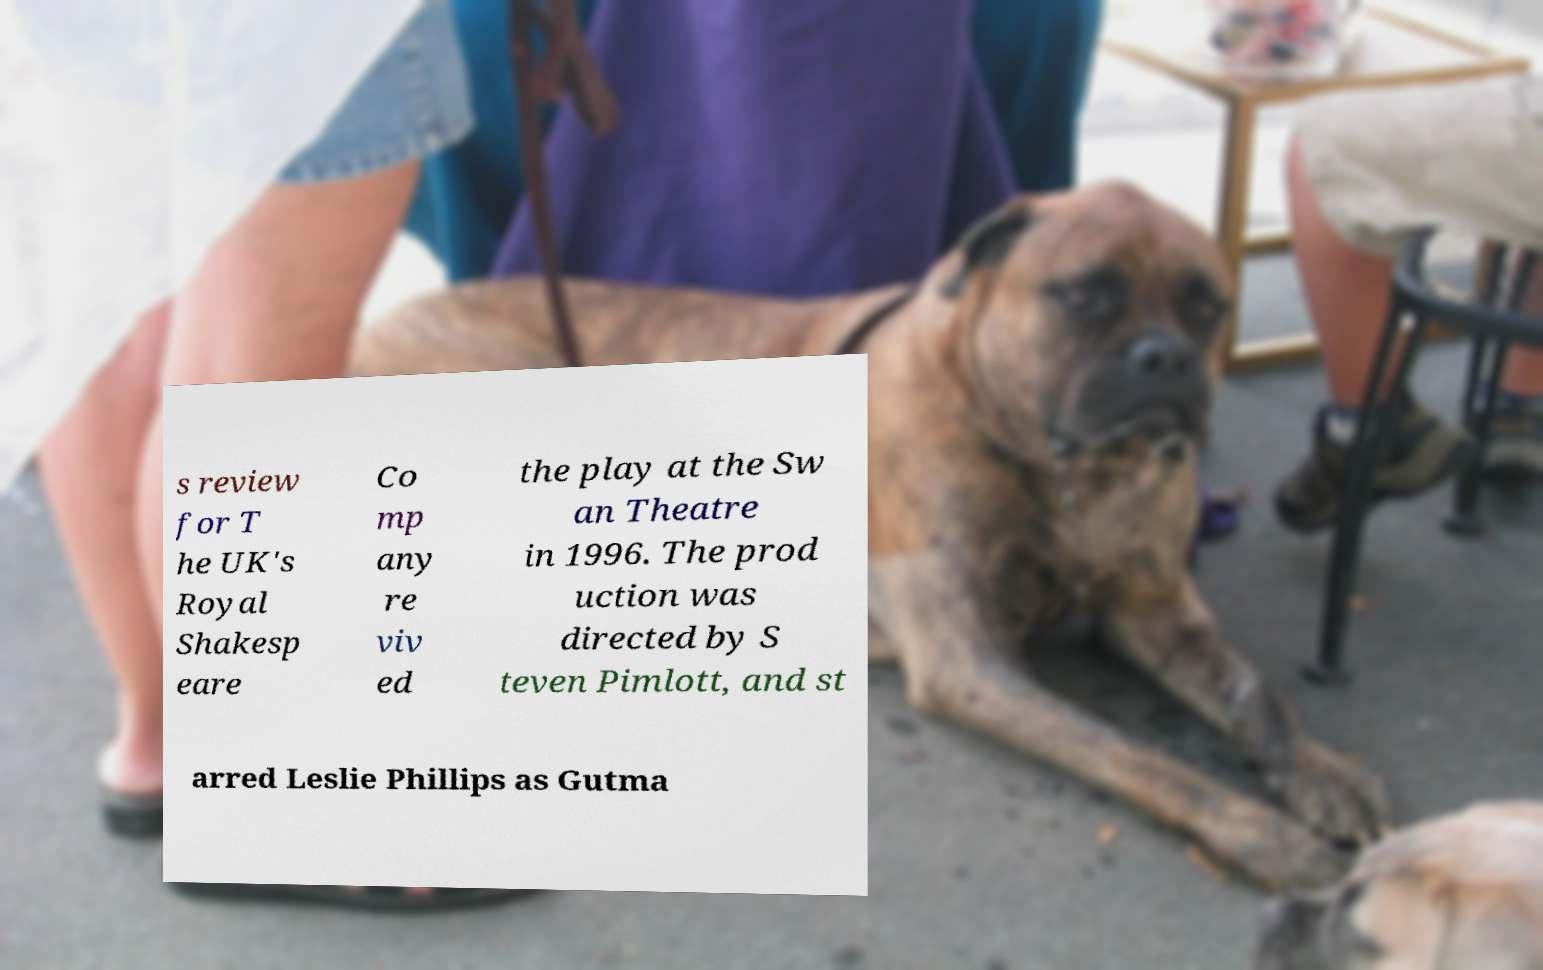Could you assist in decoding the text presented in this image and type it out clearly? s review for T he UK's Royal Shakesp eare Co mp any re viv ed the play at the Sw an Theatre in 1996. The prod uction was directed by S teven Pimlott, and st arred Leslie Phillips as Gutma 